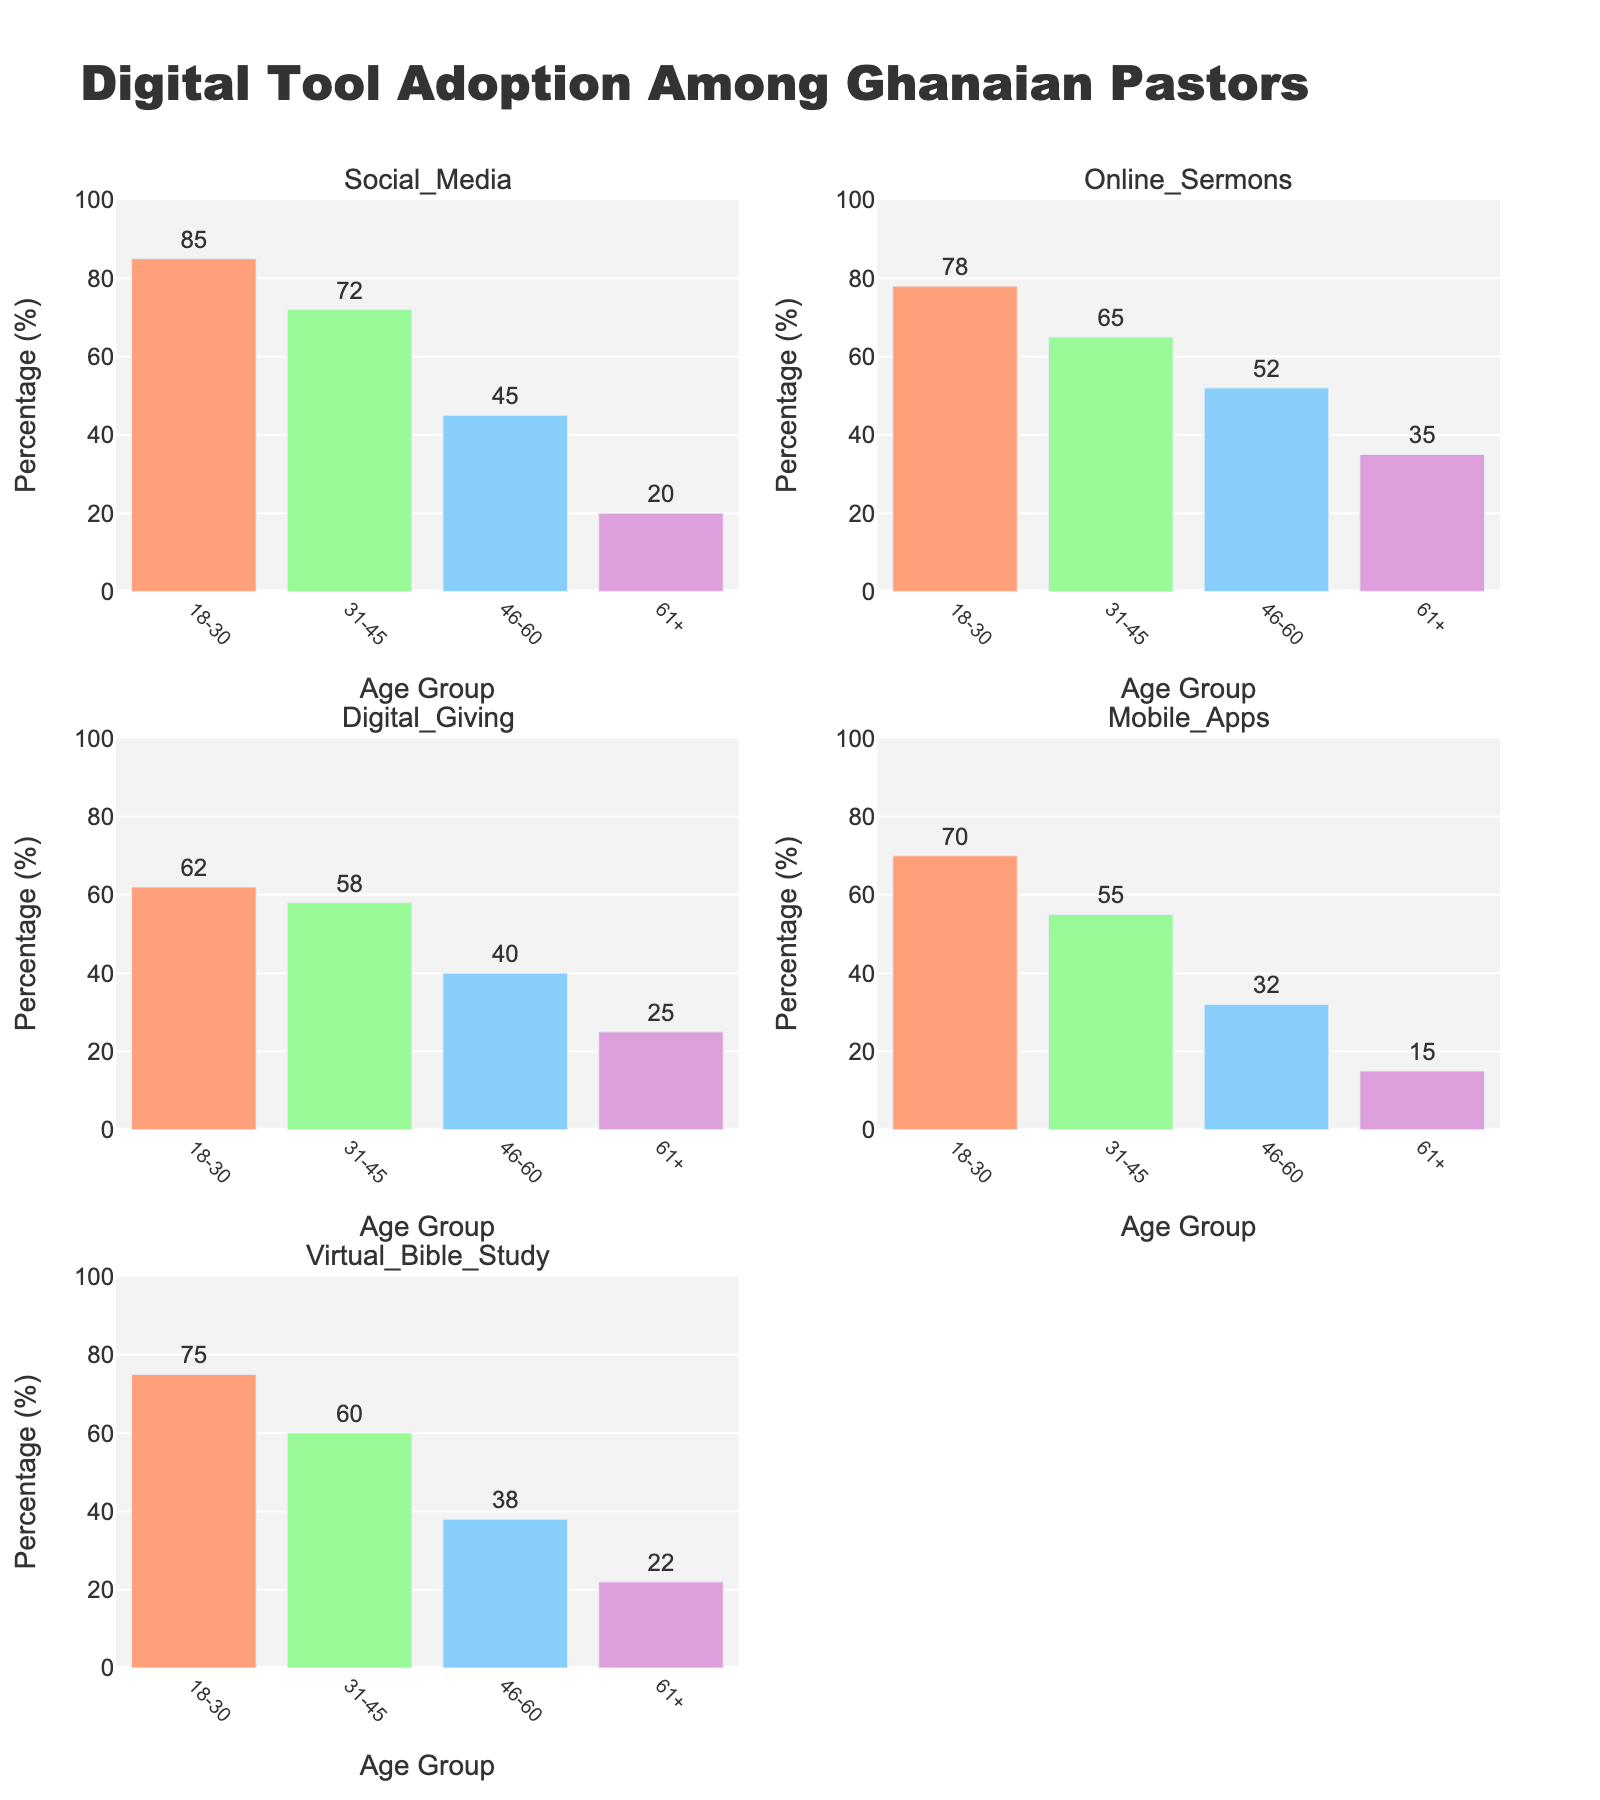What is the title of the figure? The title is usually displayed at the top of the figure. In this case, it states the main study subject or analysis.
Answer: Digital Tool Adoption Among Ghanaian Pastors Which age group has the highest percentage in Social Media adoption? Look at the subplot for Social Media and identify the highest bar. Check the x-axis label to determine the age group.
Answer: 18-30 What is the percentage of Virtual Bible Study for the age group 61+? Locate the subplot for Virtual Bible Study, find the bar corresponding to the age group 61+, and read the value.
Answer: 22 Which digital tool has the lowest adoption percentage among the age group 46-60? Check all subplots, look at the bars for the age group 46-60, and find the shortest bar.
Answer: Mobile Apps What is the average adoption percentage of Online Sermons across all age groups? Sum the percentages from Online Sermons subplot for all age groups and divide by the number of age groups (78 + 65 + 52 + 35) / 4 = 57.5
Answer: 57.5 Which age group shows the least variation in the adoption of the five digital tools? Compare the ranges of adoption percentages within each age group by looking at how close the values are to each other. 61+ has the least range (20-35).
Answer: 61+ Among the age group 31-45, which digital tool has the highest adoption percentage? Look at the bars in the 31-45 age group across all subplots and find the highest bar.
Answer: Social Media What is the difference in Digital Giving adoption between the 18-30 and 46-60 age groups? Subtract the percentage of the 46-60 age group from the 18-30 age group in the Digital Giving subplot (62 - 40).
Answer: 22 Which digital tool has the most variable adoption rates across different age groups? Check all subplots for the range of values (highest percentage minus lowest percentage). Social Media varies from 20 to 85, so its range is 65.
Answer: Social Media How many subplots are used to display the digital tools? Count the number of subplot titles provided in the code (one for each digital tool) or physically count the number of subplots in the grid.
Answer: 5 